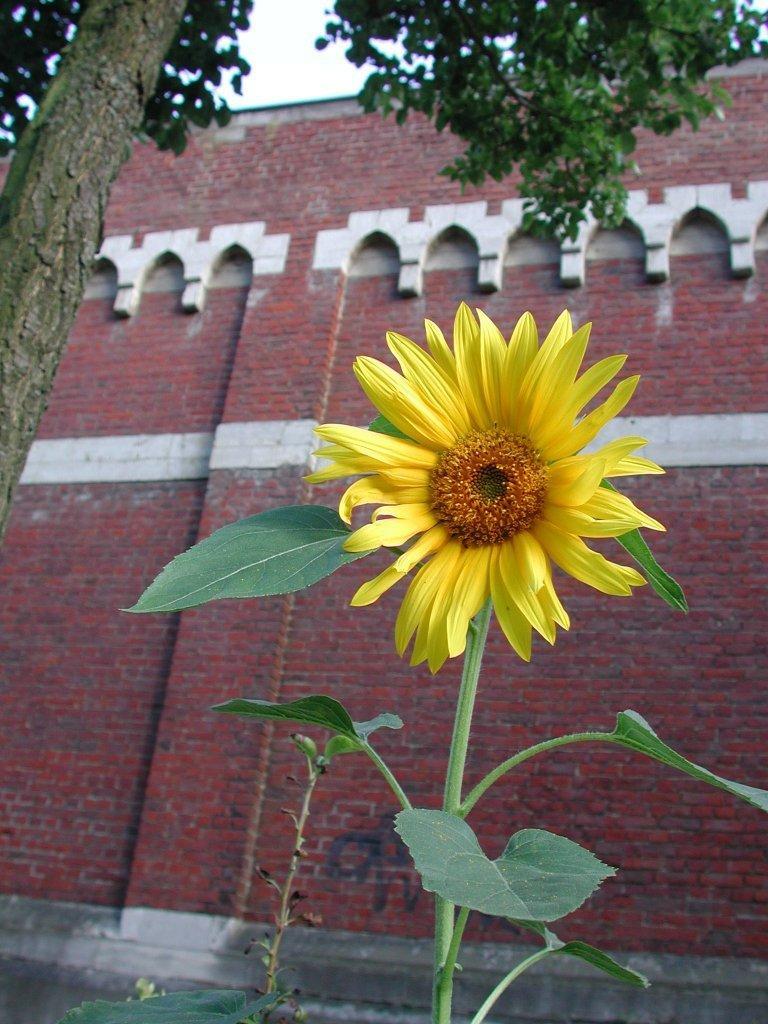Describe this image in one or two sentences. In this image in the foreground there is a flower, and in the background there is a building and trees. At the bottom there is a walkway. 